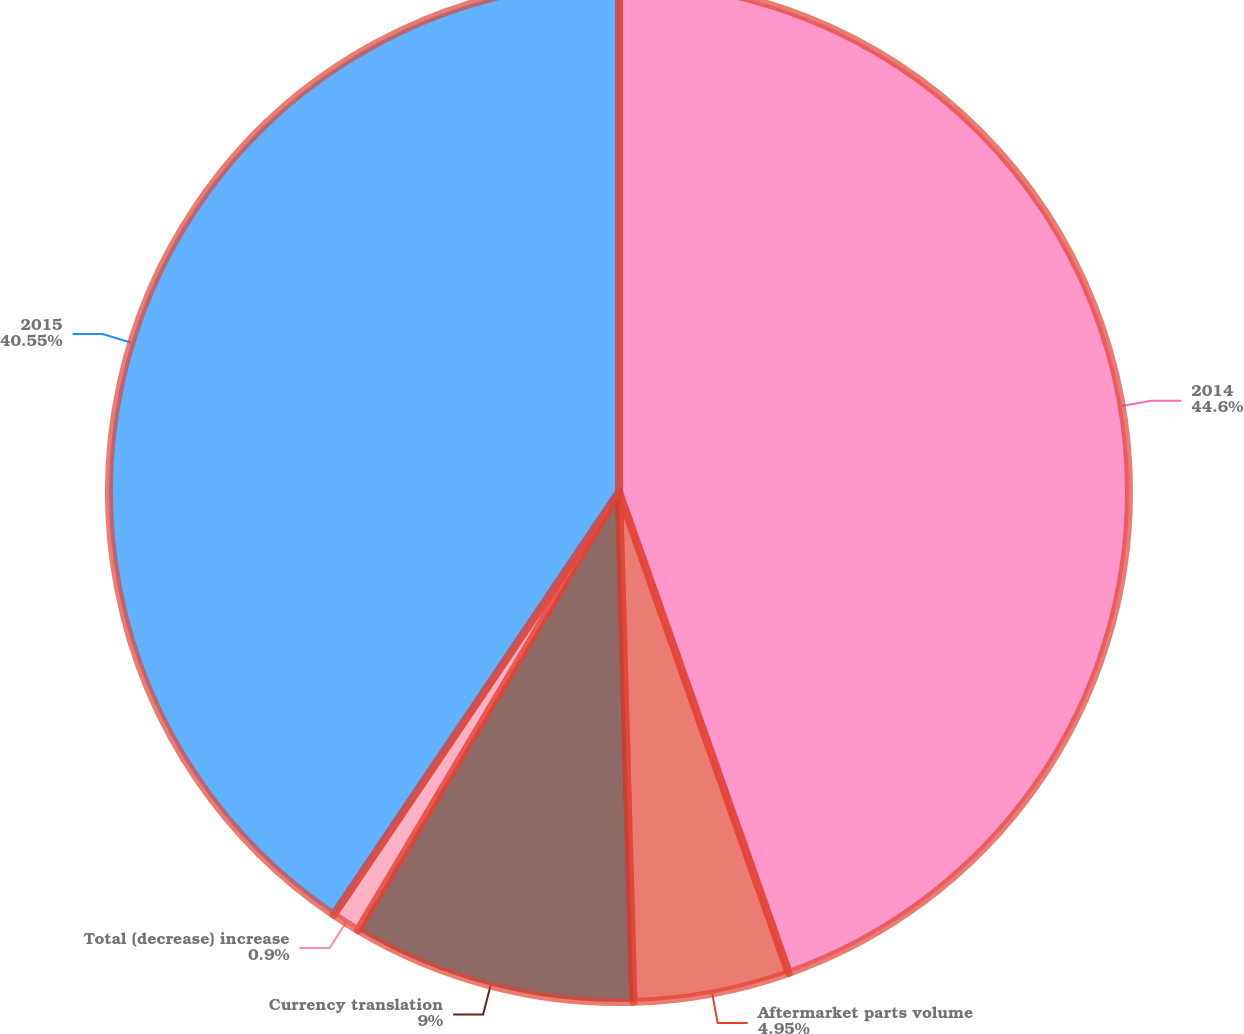<chart> <loc_0><loc_0><loc_500><loc_500><pie_chart><fcel>2014<fcel>Aftermarket parts volume<fcel>Currency translation<fcel>Total (decrease) increase<fcel>2015<nl><fcel>44.6%<fcel>4.95%<fcel>9.0%<fcel>0.9%<fcel>40.55%<nl></chart> 